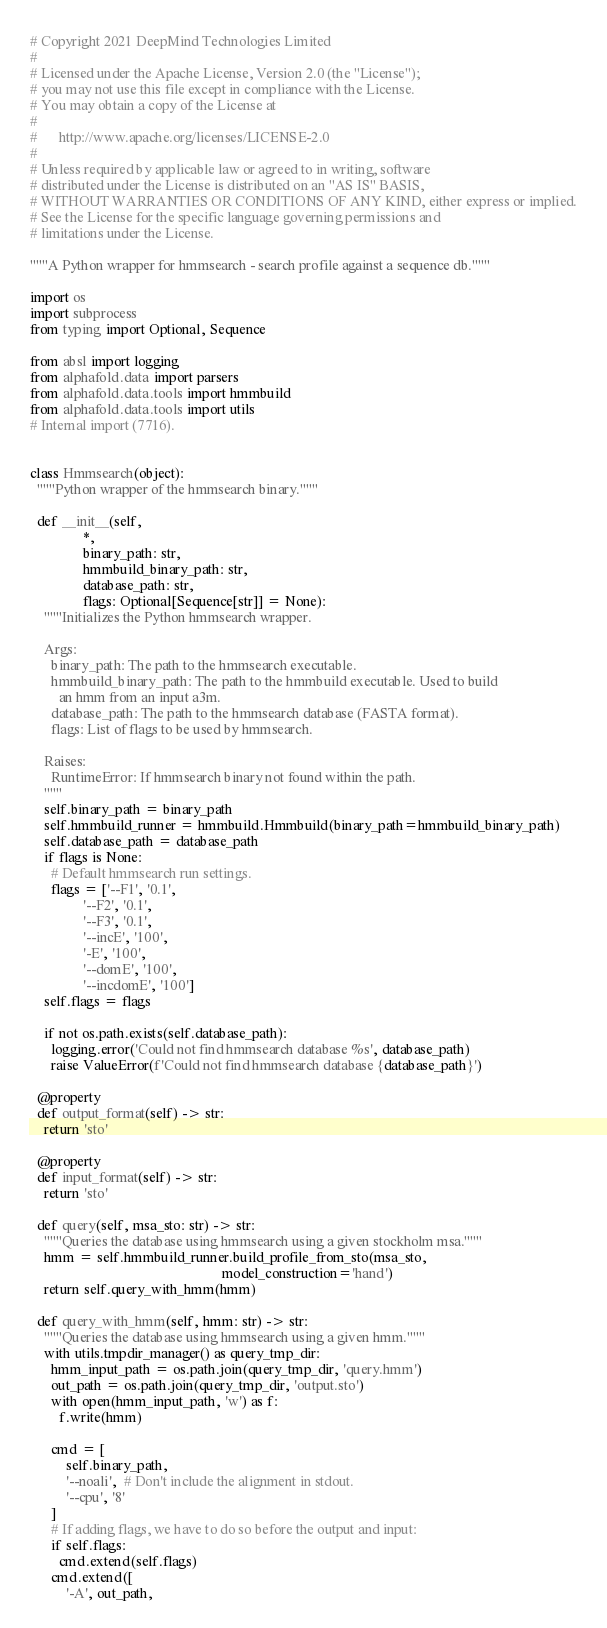Convert code to text. <code><loc_0><loc_0><loc_500><loc_500><_Python_># Copyright 2021 DeepMind Technologies Limited
#
# Licensed under the Apache License, Version 2.0 (the "License");
# you may not use this file except in compliance with the License.
# You may obtain a copy of the License at
#
#      http://www.apache.org/licenses/LICENSE-2.0
#
# Unless required by applicable law or agreed to in writing, software
# distributed under the License is distributed on an "AS IS" BASIS,
# WITHOUT WARRANTIES OR CONDITIONS OF ANY KIND, either express or implied.
# See the License for the specific language governing permissions and
# limitations under the License.

"""A Python wrapper for hmmsearch - search profile against a sequence db."""

import os
import subprocess
from typing import Optional, Sequence

from absl import logging
from alphafold.data import parsers
from alphafold.data.tools import hmmbuild
from alphafold.data.tools import utils
# Internal import (7716).


class Hmmsearch(object):
  """Python wrapper of the hmmsearch binary."""

  def __init__(self,
               *,
               binary_path: str,
               hmmbuild_binary_path: str,
               database_path: str,
               flags: Optional[Sequence[str]] = None):
    """Initializes the Python hmmsearch wrapper.

    Args:
      binary_path: The path to the hmmsearch executable.
      hmmbuild_binary_path: The path to the hmmbuild executable. Used to build
        an hmm from an input a3m.
      database_path: The path to the hmmsearch database (FASTA format).
      flags: List of flags to be used by hmmsearch.

    Raises:
      RuntimeError: If hmmsearch binary not found within the path.
    """
    self.binary_path = binary_path
    self.hmmbuild_runner = hmmbuild.Hmmbuild(binary_path=hmmbuild_binary_path)
    self.database_path = database_path
    if flags is None:
      # Default hmmsearch run settings.
      flags = ['--F1', '0.1',
               '--F2', '0.1',
               '--F3', '0.1',
               '--incE', '100',
               '-E', '100',
               '--domE', '100',
               '--incdomE', '100']
    self.flags = flags

    if not os.path.exists(self.database_path):
      logging.error('Could not find hmmsearch database %s', database_path)
      raise ValueError(f'Could not find hmmsearch database {database_path}')

  @property
  def output_format(self) -> str:
    return 'sto'

  @property
  def input_format(self) -> str:
    return 'sto'

  def query(self, msa_sto: str) -> str:
    """Queries the database using hmmsearch using a given stockholm msa."""
    hmm = self.hmmbuild_runner.build_profile_from_sto(msa_sto,
                                                      model_construction='hand')
    return self.query_with_hmm(hmm)

  def query_with_hmm(self, hmm: str) -> str:
    """Queries the database using hmmsearch using a given hmm."""
    with utils.tmpdir_manager() as query_tmp_dir:
      hmm_input_path = os.path.join(query_tmp_dir, 'query.hmm')
      out_path = os.path.join(query_tmp_dir, 'output.sto')
      with open(hmm_input_path, 'w') as f:
        f.write(hmm)

      cmd = [
          self.binary_path,
          '--noali',  # Don't include the alignment in stdout.
          '--cpu', '8'
      ]
      # If adding flags, we have to do so before the output and input:
      if self.flags:
        cmd.extend(self.flags)
      cmd.extend([
          '-A', out_path,</code> 